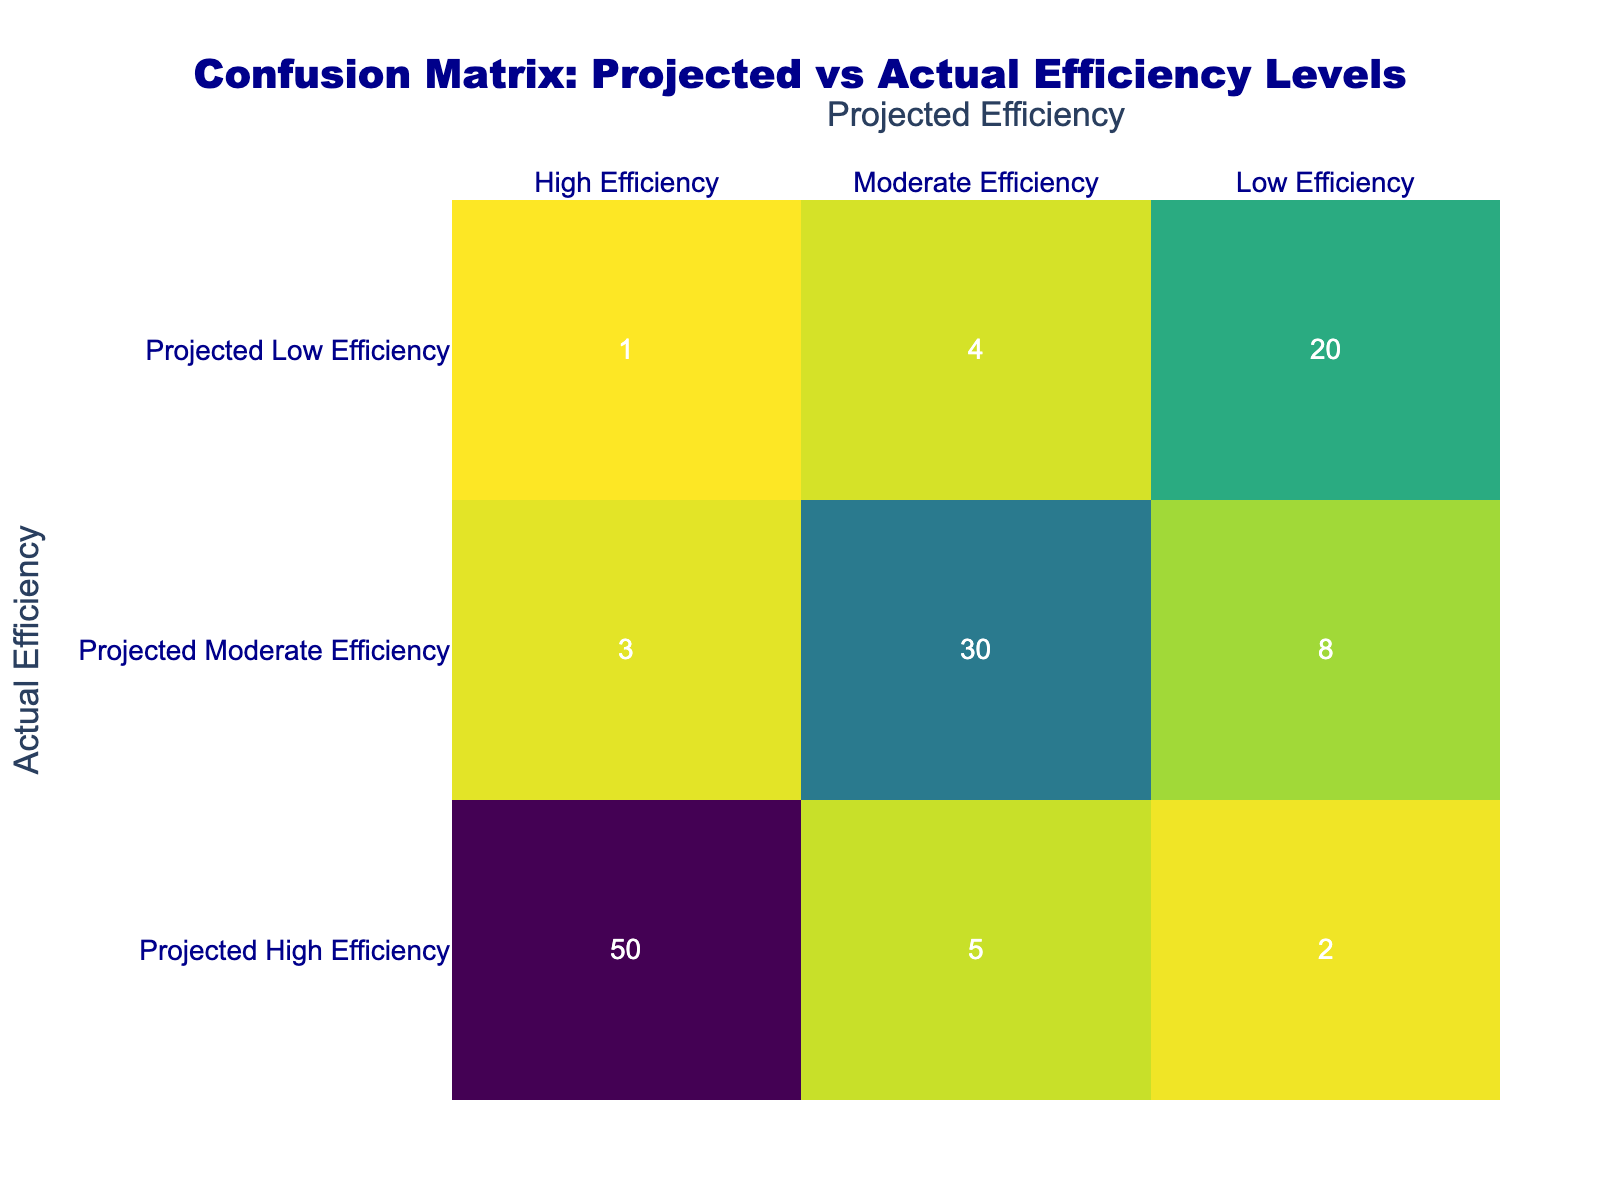What is the number of instances where the projected efficiency was rated as high efficiency and the actual efficiency was moderate efficiency? In the table, we look at the intersection of "Projected High Efficiency" and "Actual Moderate Efficiency." This cell contains a value of 5.
Answer: 5 What is the total number of instances where the actual efficiency is low efficiency? We sum the values in the "Low Efficiency" row: 2 (from Projected High Efficiency) + 8 (from Projected Moderate Efficiency) + 20 (from Projected Low Efficiency) = 30.
Answer: 30 Is there any instance where the projected efficiency was rated as low efficiency and the actual efficiency was rated as high efficiency? In the table, the cell that indicates "Projected Low Efficiency" and "Actual High Efficiency" contains a value of 1. Since there is a value, the answer is yes.
Answer: Yes What is the total number of instances for each category of projected efficiency? For "Projected High Efficiency," the total is 50 + 5 + 2 = 57; for "Projected Moderate Efficiency," it is 3 + 30 + 8 = 41; for "Projected Low Efficiency," it is 1 + 4 + 20 = 25.
Answer: High: 57, Moderate: 41, Low: 25 What is the difference in the number of instances between the high efficiency and low efficiency projected categories? We first find the total for high efficiency (57) and low efficiency (25). The difference is 57 - 25 = 32.
Answer: 32 What proportion of instances where the actual efficiency was high efficiency was accurately projected as high efficiency? The number of instances that were accurately projected as high efficiency is 50, and the total instances for high efficiency is 50 + 5 + 2 = 57. The proportion is 50/57 ≈ 0.877 or 87.7%.
Answer: 87.7% Did the actual efficiency ever achieve moderate efficiency when the projected efficiency was rated low? Referring to the table, for "Projected Low Efficiency," the "Actual Moderate Efficiency" value is 4, indicating there were instances where this occurred. Therefore, the answer is yes.
Answer: Yes What is the average number of instances across all cells in the confusion matrix? There are a total of 50 + 5 + 2 + 3 + 30 + 8 + 1 + 4 + 20 = 123 instances in total. Since there are 9 cells, we calculate the average as 123 / 9 = 13.67.
Answer: 13.67 